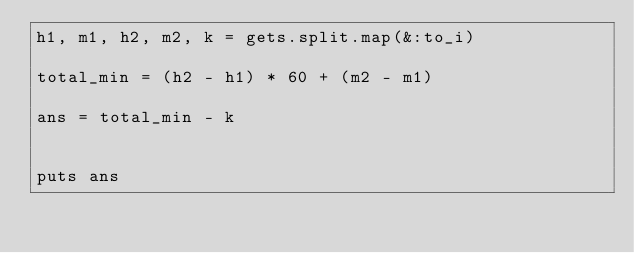<code> <loc_0><loc_0><loc_500><loc_500><_Ruby_>h1, m1, h2, m2, k = gets.split.map(&:to_i)

total_min = (h2 - h1) * 60 + (m2 - m1)

ans = total_min - k


puts ans
</code> 